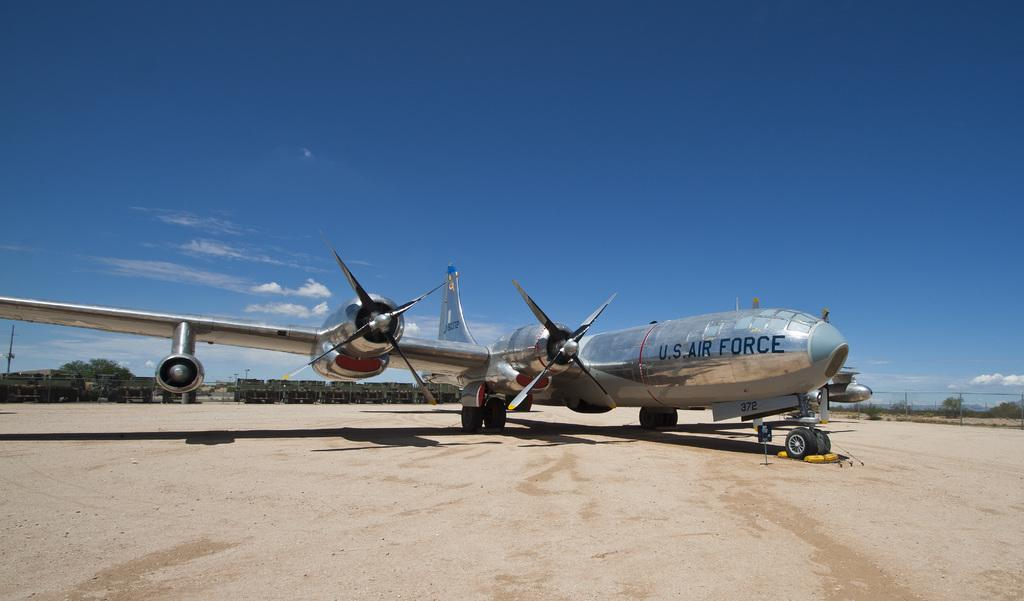<image>
Render a clear and concise summary of the photo. A massive U.S. Air Force air plane sites on a landing. 